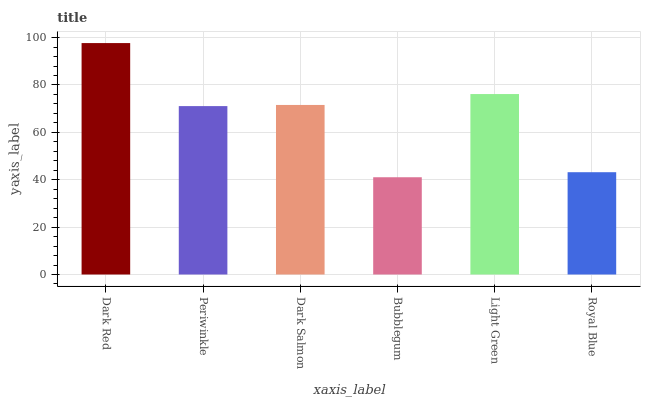Is Bubblegum the minimum?
Answer yes or no. Yes. Is Dark Red the maximum?
Answer yes or no. Yes. Is Periwinkle the minimum?
Answer yes or no. No. Is Periwinkle the maximum?
Answer yes or no. No. Is Dark Red greater than Periwinkle?
Answer yes or no. Yes. Is Periwinkle less than Dark Red?
Answer yes or no. Yes. Is Periwinkle greater than Dark Red?
Answer yes or no. No. Is Dark Red less than Periwinkle?
Answer yes or no. No. Is Dark Salmon the high median?
Answer yes or no. Yes. Is Periwinkle the low median?
Answer yes or no. Yes. Is Dark Red the high median?
Answer yes or no. No. Is Dark Red the low median?
Answer yes or no. No. 